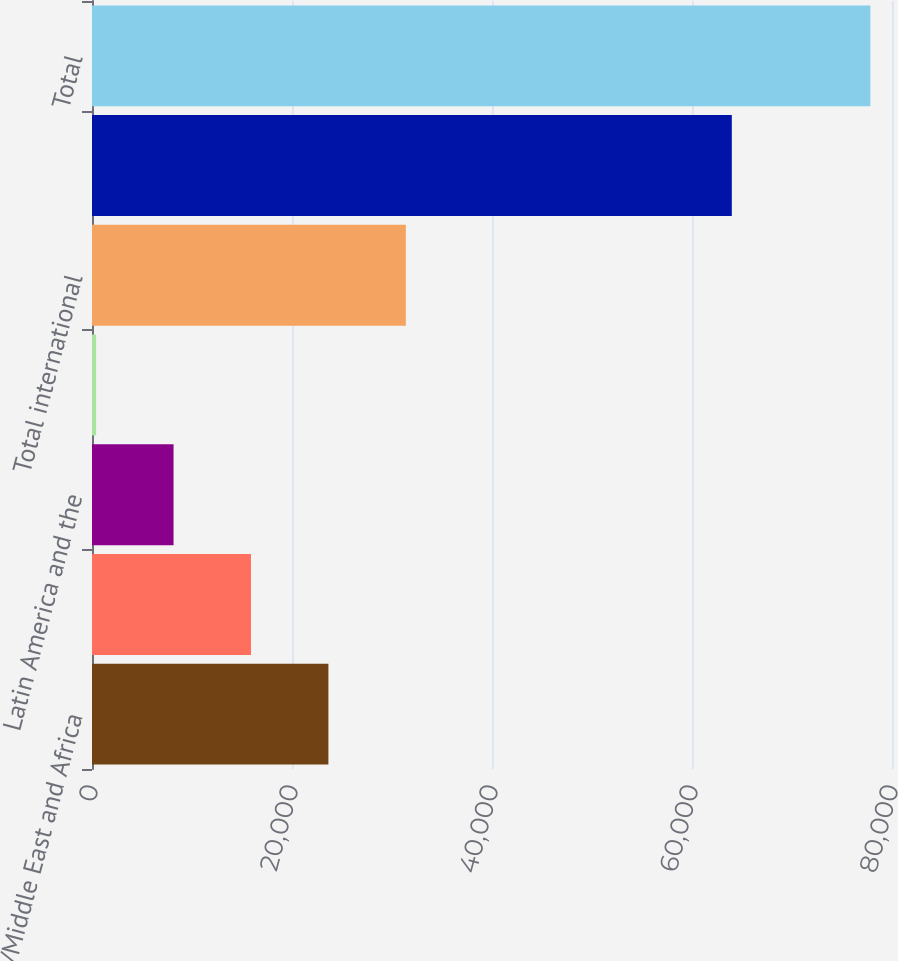Convert chart to OTSL. <chart><loc_0><loc_0><loc_500><loc_500><bar_chart><fcel>Europe/Middle East and Africa<fcel>Asia and Pacific<fcel>Latin America and the<fcel>Other<fcel>Total international<fcel>Total US<fcel>Total<nl><fcel>23639.6<fcel>15897.4<fcel>8155.2<fcel>413<fcel>31381.8<fcel>63981<fcel>77835<nl></chart> 